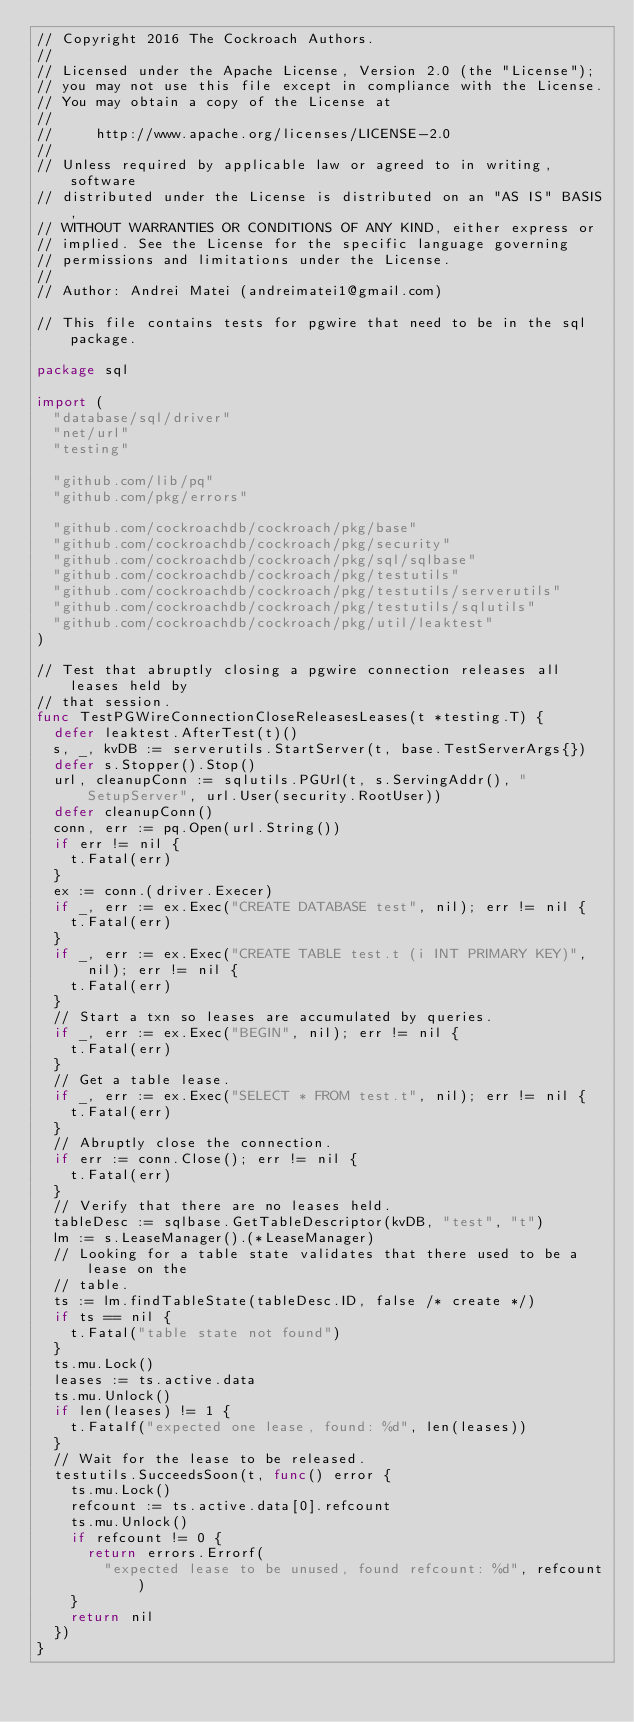Convert code to text. <code><loc_0><loc_0><loc_500><loc_500><_Go_>// Copyright 2016 The Cockroach Authors.
//
// Licensed under the Apache License, Version 2.0 (the "License");
// you may not use this file except in compliance with the License.
// You may obtain a copy of the License at
//
//     http://www.apache.org/licenses/LICENSE-2.0
//
// Unless required by applicable law or agreed to in writing, software
// distributed under the License is distributed on an "AS IS" BASIS,
// WITHOUT WARRANTIES OR CONDITIONS OF ANY KIND, either express or
// implied. See the License for the specific language governing
// permissions and limitations under the License.
//
// Author: Andrei Matei (andreimatei1@gmail.com)

// This file contains tests for pgwire that need to be in the sql package.

package sql

import (
	"database/sql/driver"
	"net/url"
	"testing"

	"github.com/lib/pq"
	"github.com/pkg/errors"

	"github.com/cockroachdb/cockroach/pkg/base"
	"github.com/cockroachdb/cockroach/pkg/security"
	"github.com/cockroachdb/cockroach/pkg/sql/sqlbase"
	"github.com/cockroachdb/cockroach/pkg/testutils"
	"github.com/cockroachdb/cockroach/pkg/testutils/serverutils"
	"github.com/cockroachdb/cockroach/pkg/testutils/sqlutils"
	"github.com/cockroachdb/cockroach/pkg/util/leaktest"
)

// Test that abruptly closing a pgwire connection releases all leases held by
// that session.
func TestPGWireConnectionCloseReleasesLeases(t *testing.T) {
	defer leaktest.AfterTest(t)()
	s, _, kvDB := serverutils.StartServer(t, base.TestServerArgs{})
	defer s.Stopper().Stop()
	url, cleanupConn := sqlutils.PGUrl(t, s.ServingAddr(), "SetupServer", url.User(security.RootUser))
	defer cleanupConn()
	conn, err := pq.Open(url.String())
	if err != nil {
		t.Fatal(err)
	}
	ex := conn.(driver.Execer)
	if _, err := ex.Exec("CREATE DATABASE test", nil); err != nil {
		t.Fatal(err)
	}
	if _, err := ex.Exec("CREATE TABLE test.t (i INT PRIMARY KEY)", nil); err != nil {
		t.Fatal(err)
	}
	// Start a txn so leases are accumulated by queries.
	if _, err := ex.Exec("BEGIN", nil); err != nil {
		t.Fatal(err)
	}
	// Get a table lease.
	if _, err := ex.Exec("SELECT * FROM test.t", nil); err != nil {
		t.Fatal(err)
	}
	// Abruptly close the connection.
	if err := conn.Close(); err != nil {
		t.Fatal(err)
	}
	// Verify that there are no leases held.
	tableDesc := sqlbase.GetTableDescriptor(kvDB, "test", "t")
	lm := s.LeaseManager().(*LeaseManager)
	// Looking for a table state validates that there used to be a lease on the
	// table.
	ts := lm.findTableState(tableDesc.ID, false /* create */)
	if ts == nil {
		t.Fatal("table state not found")
	}
	ts.mu.Lock()
	leases := ts.active.data
	ts.mu.Unlock()
	if len(leases) != 1 {
		t.Fatalf("expected one lease, found: %d", len(leases))
	}
	// Wait for the lease to be released.
	testutils.SucceedsSoon(t, func() error {
		ts.mu.Lock()
		refcount := ts.active.data[0].refcount
		ts.mu.Unlock()
		if refcount != 0 {
			return errors.Errorf(
				"expected lease to be unused, found refcount: %d", refcount)
		}
		return nil
	})
}
</code> 